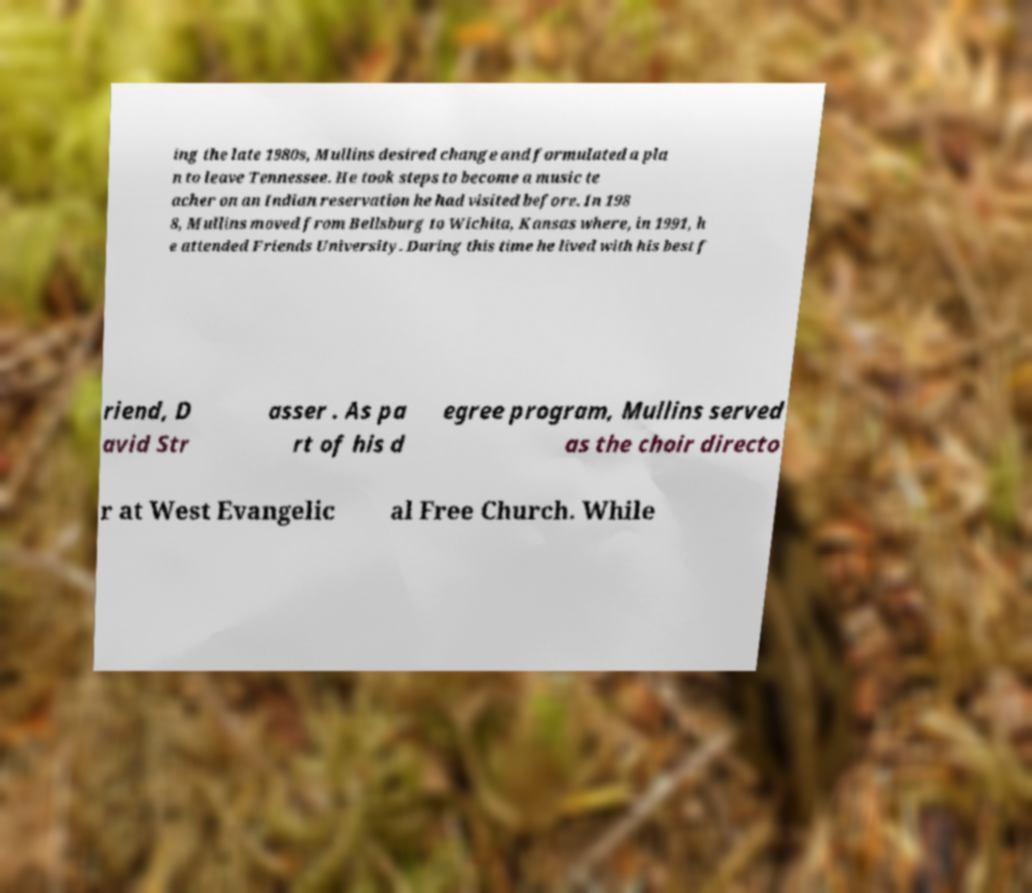Please identify and transcribe the text found in this image. ing the late 1980s, Mullins desired change and formulated a pla n to leave Tennessee. He took steps to become a music te acher on an Indian reservation he had visited before. In 198 8, Mullins moved from Bellsburg to Wichita, Kansas where, in 1991, h e attended Friends University. During this time he lived with his best f riend, D avid Str asser . As pa rt of his d egree program, Mullins served as the choir directo r at West Evangelic al Free Church. While 